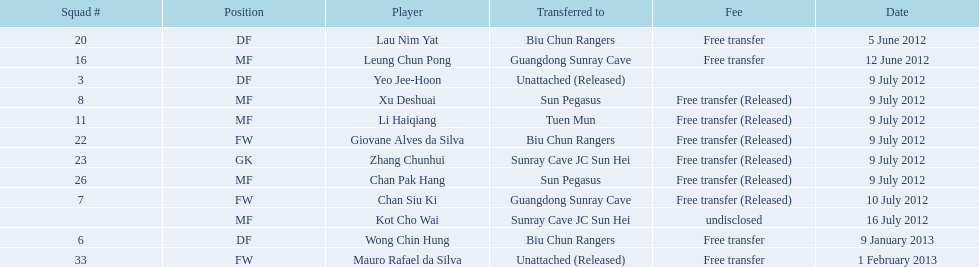Which players played during the 2012-13 south china aa season? Lau Nim Yat, Leung Chun Pong, Yeo Jee-Hoon, Xu Deshuai, Li Haiqiang, Giovane Alves da Silva, Zhang Chunhui, Chan Pak Hang, Chan Siu Ki, Kot Cho Wai, Wong Chin Hung, Mauro Rafael da Silva. Of these, which were free transfers that were not released? Lau Nim Yat, Leung Chun Pong, Wong Chin Hung, Mauro Rafael da Silva. Of these, which were in squad # 6? Wong Chin Hung. What was the date of his transfer? 9 January 2013. 